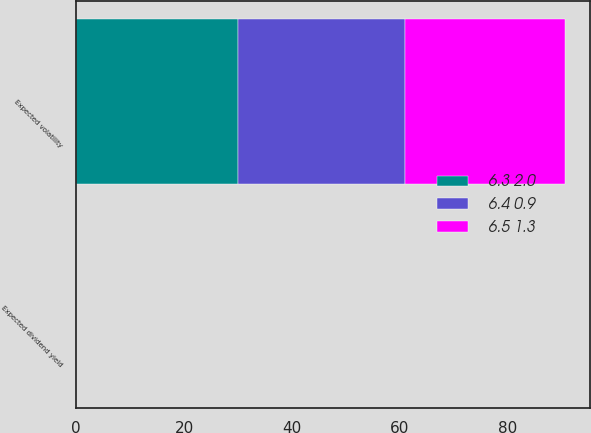Convert chart to OTSL. <chart><loc_0><loc_0><loc_500><loc_500><stacked_bar_chart><ecel><fcel>Expected volatility<fcel>Expected dividend yield<nl><fcel>6.5 1.3<fcel>29.6<fcel>0<nl><fcel>6.3 2.0<fcel>29.9<fcel>0<nl><fcel>6.4 0.9<fcel>31.1<fcel>0<nl></chart> 